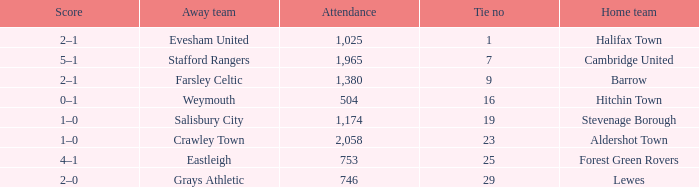What is the highest attendance for games with stevenage borough at home? 1174.0. 